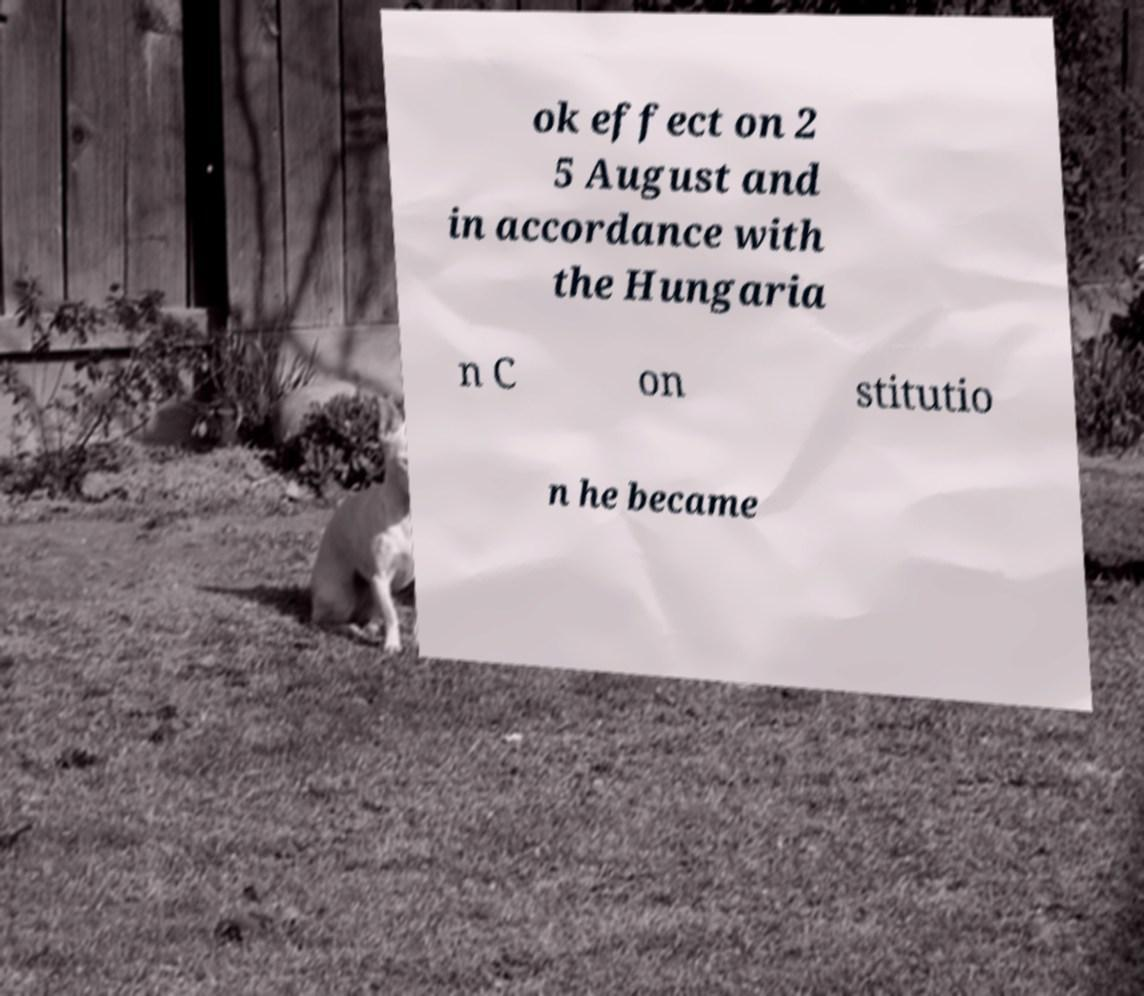I need the written content from this picture converted into text. Can you do that? ok effect on 2 5 August and in accordance with the Hungaria n C on stitutio n he became 